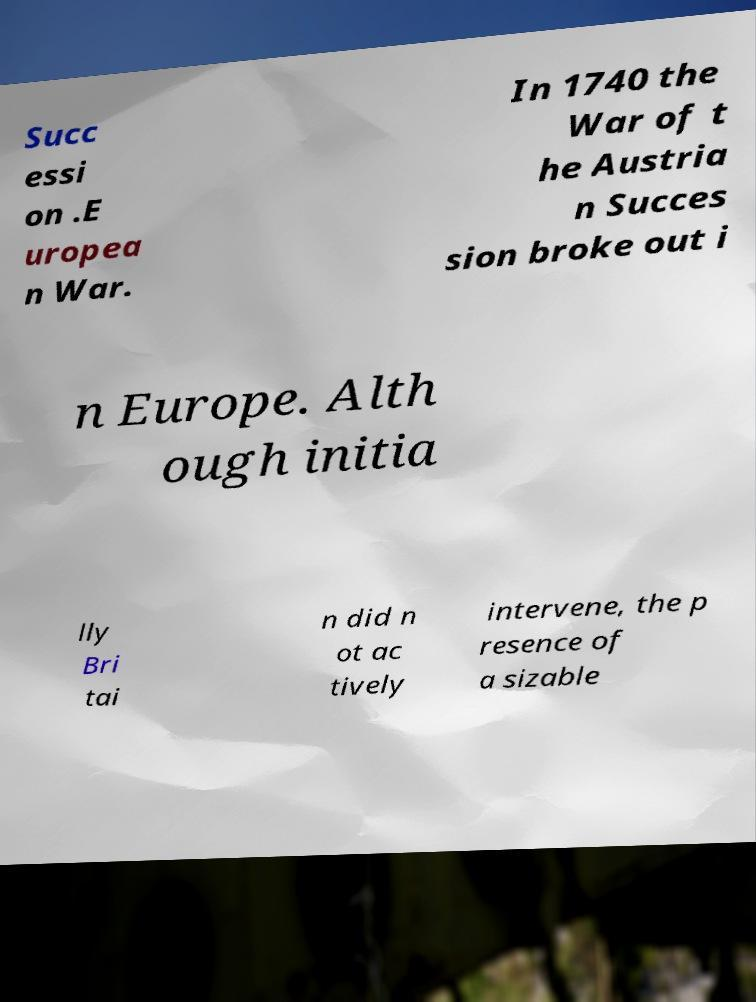There's text embedded in this image that I need extracted. Can you transcribe it verbatim? Succ essi on .E uropea n War. In 1740 the War of t he Austria n Succes sion broke out i n Europe. Alth ough initia lly Bri tai n did n ot ac tively intervene, the p resence of a sizable 